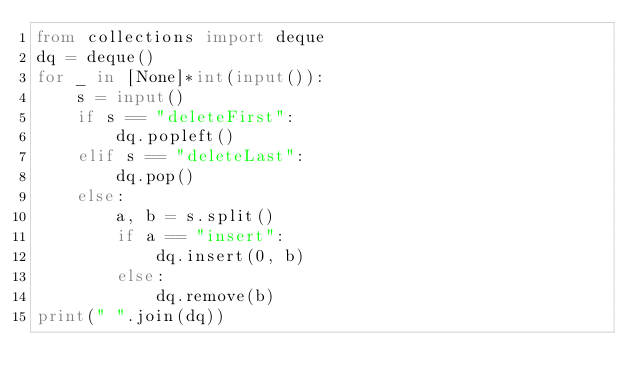<code> <loc_0><loc_0><loc_500><loc_500><_Python_>from collections import deque
dq = deque()
for _ in [None]*int(input()):
    s = input()
    if s == "deleteFirst":
        dq.popleft()
    elif s == "deleteLast":
        dq.pop()
    else:
        a, b = s.split()
        if a == "insert":
            dq.insert(0, b)
        else:
            dq.remove(b)
print(" ".join(dq))</code> 